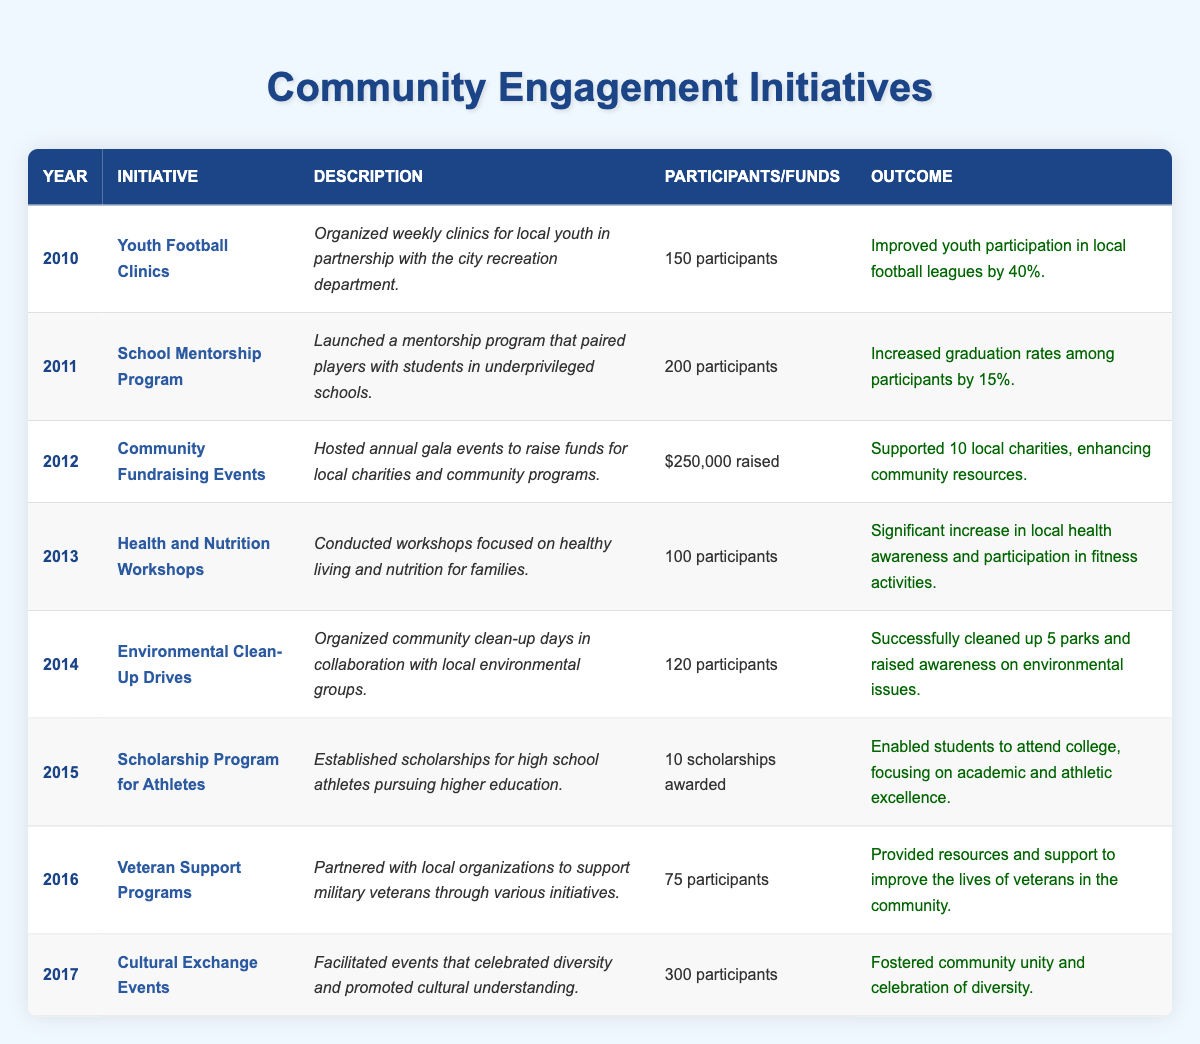What was the initiative implemented in 2012? According to the table, the initiative in 2012 is "Community Fundraising Events". This can be identified by finding the row for the year 2012 in the table.
Answer: Community Fundraising Events How many participants were involved in the Youth Football Clinics? The table shows that the Youth Football Clinics in 2010 had 150 participants listed in the corresponding cell.
Answer: 150 participants Which initiative had the highest number of participants? By examining the "Participants" column, the Cultural Exchange Events in 2017 had the highest number, with 300 participants, which is greater than any other initiative.
Answer: 300 participants Did the School Mentorship Program have a positive impact on graduation rates? The outcome for the School Mentorship Program states that graduation rates among participants increased by 15%, indicating a positive impact.
Answer: Yes How many initiatives focused on health and nutrition from 2010 to 2017? The initiatives that focused on health and nutrition are: Health and Nutrition Workshops (2013). Since there is only one such initiative during these years, the answer is one.
Answer: 1 What is the total amount of funds raised from Community Fundraising Events? According to the table, the funds raised from these events in 2012 were $250,000, which is the only financial data provided for community initiatives.
Answer: $250,000 Which initiative took place in 2014 and how many participants were involved? In 2014, the initiative was "Environmental Clean-Up Drives", which involved 120 participants as detailed in the table.
Answer: Environmental Clean-Up Drives, 120 participants What was the average number of participants across all initiatives from 2010 to 2017? To find the average, sum the participants for each initiative: 150 + 200 + (0) + 100 + 120 + (10, represented here for scholarships) + 75 + 300 = 955. Divide by the total count of initiatives (8): 955/8 = 119.375. Rounded gives an average of approximately 119 participants.
Answer: Approximately 119 participants Did the Veteran Support Programs have more participants than the Health and Nutrition Workshops? The table shows the Veteran Support Programs had 75 participants while the Health and Nutrition Workshops had 100 participants. Comparing these two numbers reveals that 100 (Health and Nutrition) is greater than 75 (Veteran Support).
Answer: No What were the outcomes of the Cultural Exchange Events? The table states that the outcome of the Cultural Exchange Events in 2017 was fostering community unity and celebration of diversity, which can be found in the corresponding row of the table.
Answer: Fostered community unity and celebration of diversity 